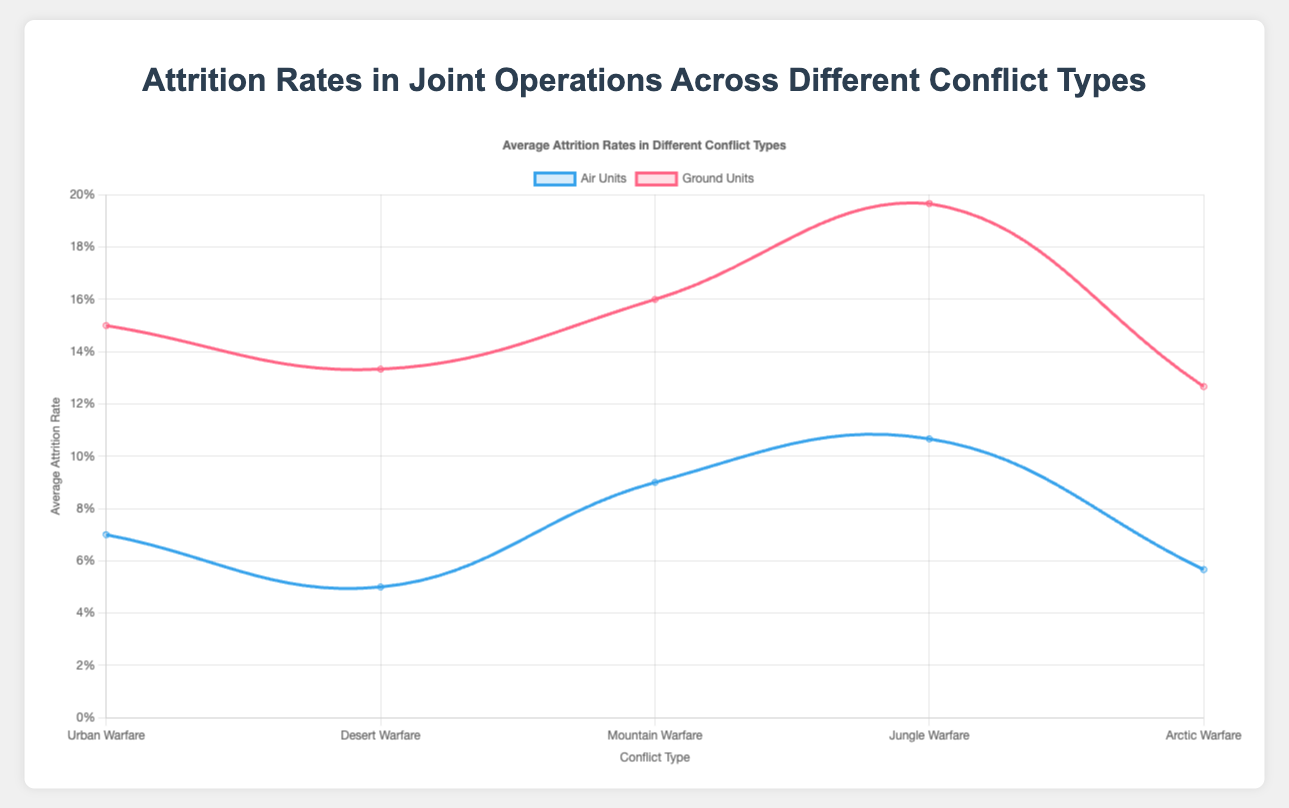What is the average attrition rate for air units in Urban Warfare? To find the average attrition rate for air units in Urban Warfare, locate the corresponding data points on the plot, then simply read the value from the chart.
Answer: 0.07 Which type of warfare has the highest attrition rate for ground units? Compare the heights of the lines for ground units across different conflict types. The highest point indicates the highest attrition rate, which is in Jungle Warfare.
Answer: Jungle Warfare In which conflict type does the F-16 Falcon have its highest attrition rate? Identify the points for the F-16 Falcon in different conflict types. The highest attrition rate can be found in Jungle Warfare.
Answer: Jungle Warfare Is the attrition rate of Apache Helicopter higher in Mountain Warfare or Urban Warfare? Locate the data points for the Apache Helicopter in both Mountain Warfare and Urban Warfare, then compare their heights. The Mountain Warfare attrition rate is higher.
Answer: Mountain Warfare What is the combined average attrition rate of the M1 Abrams in Urban and Desert Warfare? Sum the attrition rates of the M1 Abrams in Urban (0.12) and Desert Warfare (0.10) and then divide by 2. Calculation: (0.12 + 0.10) / 2 = 0.11
Answer: 0.11 Which unit has the lowest attrition rate in Arctic Warfare? Locate and compare the attrition rates of all units (both air and ground) in Arctic Warfare. The F-35 Lightning II has the lowest attrition rate at 0.04.
Answer: F-35 Lightning II How much higher is the attrition rate of the Humvee in Jungle Warfare compared to Desert Warfare? Find the attrition rates of the Humvee in Jungle (0.20) and Desert Warfare (0.16) and calculate the difference. Calculation: 0.20 - 0.16 = 0.04
Answer: 0.04 Which conflict type shows the biggest disparity between air and ground units' average attrition rates? Calculate the disparity for each conflict by subtracting the average attrition rate of air units from that of ground units, then compare these disparities. The biggest disparity can be seen in Jungle Warfare.
Answer: Jungle Warfare Which air unit has the highest average attrition rate across all conflict types? Compare the attrition rates of each air unit across all conflict types and determine the highest one. The Black Hawk Helicopter has the highest average attrition rate in Jungle Warfare at 0.12.
Answer: Black Hawk Helicopter 